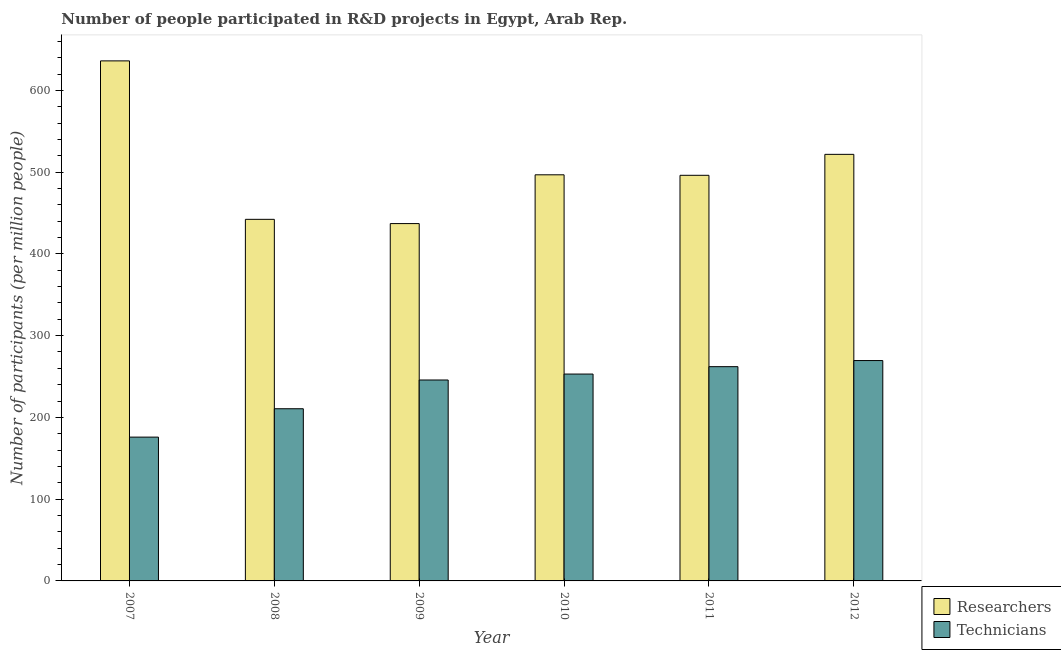How many groups of bars are there?
Offer a terse response. 6. How many bars are there on the 6th tick from the right?
Offer a terse response. 2. What is the label of the 6th group of bars from the left?
Offer a terse response. 2012. In how many cases, is the number of bars for a given year not equal to the number of legend labels?
Your answer should be compact. 0. What is the number of technicians in 2009?
Keep it short and to the point. 245.77. Across all years, what is the maximum number of researchers?
Give a very brief answer. 636.08. Across all years, what is the minimum number of researchers?
Your answer should be compact. 437.06. In which year was the number of researchers maximum?
Give a very brief answer. 2007. What is the total number of technicians in the graph?
Your response must be concise. 1416.87. What is the difference between the number of researchers in 2011 and that in 2012?
Offer a terse response. -25.62. What is the difference between the number of researchers in 2011 and the number of technicians in 2007?
Provide a short and direct response. -139.96. What is the average number of researchers per year?
Offer a very short reply. 505. What is the ratio of the number of researchers in 2008 to that in 2011?
Ensure brevity in your answer.  0.89. What is the difference between the highest and the second highest number of researchers?
Provide a short and direct response. 114.34. What is the difference between the highest and the lowest number of researchers?
Provide a succinct answer. 199.02. What does the 1st bar from the left in 2008 represents?
Your response must be concise. Researchers. What does the 1st bar from the right in 2008 represents?
Make the answer very short. Technicians. Are all the bars in the graph horizontal?
Your answer should be compact. No. What is the difference between two consecutive major ticks on the Y-axis?
Give a very brief answer. 100. Does the graph contain grids?
Offer a terse response. No. Where does the legend appear in the graph?
Your answer should be compact. Bottom right. How many legend labels are there?
Your response must be concise. 2. How are the legend labels stacked?
Keep it short and to the point. Vertical. What is the title of the graph?
Give a very brief answer. Number of people participated in R&D projects in Egypt, Arab Rep. What is the label or title of the Y-axis?
Keep it short and to the point. Number of participants (per million people). What is the Number of participants (per million people) in Researchers in 2007?
Your answer should be compact. 636.08. What is the Number of participants (per million people) in Technicians in 2007?
Offer a very short reply. 175.89. What is the Number of participants (per million people) of Researchers in 2008?
Ensure brevity in your answer.  442.27. What is the Number of participants (per million people) in Technicians in 2008?
Your answer should be compact. 210.6. What is the Number of participants (per million people) in Researchers in 2009?
Give a very brief answer. 437.06. What is the Number of participants (per million people) in Technicians in 2009?
Offer a very short reply. 245.77. What is the Number of participants (per million people) in Researchers in 2010?
Your answer should be very brief. 496.73. What is the Number of participants (per million people) in Technicians in 2010?
Make the answer very short. 253.02. What is the Number of participants (per million people) in Researchers in 2011?
Provide a succinct answer. 496.12. What is the Number of participants (per million people) in Technicians in 2011?
Offer a very short reply. 262.07. What is the Number of participants (per million people) in Researchers in 2012?
Provide a short and direct response. 521.74. What is the Number of participants (per million people) in Technicians in 2012?
Your answer should be compact. 269.53. Across all years, what is the maximum Number of participants (per million people) of Researchers?
Your answer should be compact. 636.08. Across all years, what is the maximum Number of participants (per million people) in Technicians?
Your answer should be compact. 269.53. Across all years, what is the minimum Number of participants (per million people) in Researchers?
Offer a terse response. 437.06. Across all years, what is the minimum Number of participants (per million people) in Technicians?
Offer a very short reply. 175.89. What is the total Number of participants (per million people) in Researchers in the graph?
Your answer should be compact. 3029.99. What is the total Number of participants (per million people) of Technicians in the graph?
Offer a very short reply. 1416.87. What is the difference between the Number of participants (per million people) in Researchers in 2007 and that in 2008?
Offer a very short reply. 193.81. What is the difference between the Number of participants (per million people) in Technicians in 2007 and that in 2008?
Your answer should be very brief. -34.71. What is the difference between the Number of participants (per million people) in Researchers in 2007 and that in 2009?
Make the answer very short. 199.02. What is the difference between the Number of participants (per million people) in Technicians in 2007 and that in 2009?
Ensure brevity in your answer.  -69.88. What is the difference between the Number of participants (per million people) in Researchers in 2007 and that in 2010?
Make the answer very short. 139.35. What is the difference between the Number of participants (per million people) in Technicians in 2007 and that in 2010?
Your answer should be very brief. -77.13. What is the difference between the Number of participants (per million people) in Researchers in 2007 and that in 2011?
Ensure brevity in your answer.  139.96. What is the difference between the Number of participants (per million people) in Technicians in 2007 and that in 2011?
Make the answer very short. -86.18. What is the difference between the Number of participants (per million people) in Researchers in 2007 and that in 2012?
Give a very brief answer. 114.34. What is the difference between the Number of participants (per million people) of Technicians in 2007 and that in 2012?
Provide a short and direct response. -93.64. What is the difference between the Number of participants (per million people) of Researchers in 2008 and that in 2009?
Keep it short and to the point. 5.21. What is the difference between the Number of participants (per million people) in Technicians in 2008 and that in 2009?
Provide a short and direct response. -35.17. What is the difference between the Number of participants (per million people) in Researchers in 2008 and that in 2010?
Provide a succinct answer. -54.46. What is the difference between the Number of participants (per million people) in Technicians in 2008 and that in 2010?
Keep it short and to the point. -42.42. What is the difference between the Number of participants (per million people) of Researchers in 2008 and that in 2011?
Your answer should be very brief. -53.85. What is the difference between the Number of participants (per million people) of Technicians in 2008 and that in 2011?
Your answer should be very brief. -51.47. What is the difference between the Number of participants (per million people) of Researchers in 2008 and that in 2012?
Keep it short and to the point. -79.47. What is the difference between the Number of participants (per million people) in Technicians in 2008 and that in 2012?
Ensure brevity in your answer.  -58.93. What is the difference between the Number of participants (per million people) in Researchers in 2009 and that in 2010?
Give a very brief answer. -59.67. What is the difference between the Number of participants (per million people) of Technicians in 2009 and that in 2010?
Offer a very short reply. -7.25. What is the difference between the Number of participants (per million people) in Researchers in 2009 and that in 2011?
Offer a very short reply. -59.06. What is the difference between the Number of participants (per million people) in Technicians in 2009 and that in 2011?
Make the answer very short. -16.3. What is the difference between the Number of participants (per million people) in Researchers in 2009 and that in 2012?
Provide a succinct answer. -84.68. What is the difference between the Number of participants (per million people) in Technicians in 2009 and that in 2012?
Keep it short and to the point. -23.76. What is the difference between the Number of participants (per million people) of Researchers in 2010 and that in 2011?
Provide a short and direct response. 0.61. What is the difference between the Number of participants (per million people) of Technicians in 2010 and that in 2011?
Your response must be concise. -9.05. What is the difference between the Number of participants (per million people) in Researchers in 2010 and that in 2012?
Offer a very short reply. -25.01. What is the difference between the Number of participants (per million people) of Technicians in 2010 and that in 2012?
Provide a short and direct response. -16.51. What is the difference between the Number of participants (per million people) in Researchers in 2011 and that in 2012?
Provide a short and direct response. -25.62. What is the difference between the Number of participants (per million people) in Technicians in 2011 and that in 2012?
Provide a short and direct response. -7.46. What is the difference between the Number of participants (per million people) in Researchers in 2007 and the Number of participants (per million people) in Technicians in 2008?
Ensure brevity in your answer.  425.48. What is the difference between the Number of participants (per million people) of Researchers in 2007 and the Number of participants (per million people) of Technicians in 2009?
Offer a terse response. 390.31. What is the difference between the Number of participants (per million people) in Researchers in 2007 and the Number of participants (per million people) in Technicians in 2010?
Offer a very short reply. 383.06. What is the difference between the Number of participants (per million people) in Researchers in 2007 and the Number of participants (per million people) in Technicians in 2011?
Keep it short and to the point. 374.01. What is the difference between the Number of participants (per million people) of Researchers in 2007 and the Number of participants (per million people) of Technicians in 2012?
Your answer should be compact. 366.55. What is the difference between the Number of participants (per million people) in Researchers in 2008 and the Number of participants (per million people) in Technicians in 2009?
Make the answer very short. 196.5. What is the difference between the Number of participants (per million people) of Researchers in 2008 and the Number of participants (per million people) of Technicians in 2010?
Keep it short and to the point. 189.25. What is the difference between the Number of participants (per million people) of Researchers in 2008 and the Number of participants (per million people) of Technicians in 2011?
Make the answer very short. 180.2. What is the difference between the Number of participants (per million people) in Researchers in 2008 and the Number of participants (per million people) in Technicians in 2012?
Ensure brevity in your answer.  172.74. What is the difference between the Number of participants (per million people) in Researchers in 2009 and the Number of participants (per million people) in Technicians in 2010?
Offer a terse response. 184.04. What is the difference between the Number of participants (per million people) of Researchers in 2009 and the Number of participants (per million people) of Technicians in 2011?
Your answer should be compact. 174.99. What is the difference between the Number of participants (per million people) of Researchers in 2009 and the Number of participants (per million people) of Technicians in 2012?
Give a very brief answer. 167.53. What is the difference between the Number of participants (per million people) of Researchers in 2010 and the Number of participants (per million people) of Technicians in 2011?
Ensure brevity in your answer.  234.66. What is the difference between the Number of participants (per million people) of Researchers in 2010 and the Number of participants (per million people) of Technicians in 2012?
Your answer should be compact. 227.2. What is the difference between the Number of participants (per million people) of Researchers in 2011 and the Number of participants (per million people) of Technicians in 2012?
Offer a very short reply. 226.59. What is the average Number of participants (per million people) in Researchers per year?
Offer a very short reply. 505. What is the average Number of participants (per million people) of Technicians per year?
Your answer should be very brief. 236.14. In the year 2007, what is the difference between the Number of participants (per million people) in Researchers and Number of participants (per million people) in Technicians?
Offer a very short reply. 460.19. In the year 2008, what is the difference between the Number of participants (per million people) of Researchers and Number of participants (per million people) of Technicians?
Your answer should be very brief. 231.67. In the year 2009, what is the difference between the Number of participants (per million people) of Researchers and Number of participants (per million people) of Technicians?
Your response must be concise. 191.29. In the year 2010, what is the difference between the Number of participants (per million people) of Researchers and Number of participants (per million people) of Technicians?
Your response must be concise. 243.71. In the year 2011, what is the difference between the Number of participants (per million people) of Researchers and Number of participants (per million people) of Technicians?
Give a very brief answer. 234.05. In the year 2012, what is the difference between the Number of participants (per million people) of Researchers and Number of participants (per million people) of Technicians?
Your answer should be very brief. 252.21. What is the ratio of the Number of participants (per million people) in Researchers in 2007 to that in 2008?
Ensure brevity in your answer.  1.44. What is the ratio of the Number of participants (per million people) of Technicians in 2007 to that in 2008?
Provide a short and direct response. 0.84. What is the ratio of the Number of participants (per million people) of Researchers in 2007 to that in 2009?
Make the answer very short. 1.46. What is the ratio of the Number of participants (per million people) of Technicians in 2007 to that in 2009?
Provide a succinct answer. 0.72. What is the ratio of the Number of participants (per million people) in Researchers in 2007 to that in 2010?
Provide a succinct answer. 1.28. What is the ratio of the Number of participants (per million people) in Technicians in 2007 to that in 2010?
Offer a very short reply. 0.7. What is the ratio of the Number of participants (per million people) in Researchers in 2007 to that in 2011?
Provide a succinct answer. 1.28. What is the ratio of the Number of participants (per million people) in Technicians in 2007 to that in 2011?
Provide a succinct answer. 0.67. What is the ratio of the Number of participants (per million people) of Researchers in 2007 to that in 2012?
Offer a very short reply. 1.22. What is the ratio of the Number of participants (per million people) in Technicians in 2007 to that in 2012?
Your response must be concise. 0.65. What is the ratio of the Number of participants (per million people) in Researchers in 2008 to that in 2009?
Provide a short and direct response. 1.01. What is the ratio of the Number of participants (per million people) of Technicians in 2008 to that in 2009?
Offer a terse response. 0.86. What is the ratio of the Number of participants (per million people) in Researchers in 2008 to that in 2010?
Offer a terse response. 0.89. What is the ratio of the Number of participants (per million people) in Technicians in 2008 to that in 2010?
Your response must be concise. 0.83. What is the ratio of the Number of participants (per million people) of Researchers in 2008 to that in 2011?
Offer a terse response. 0.89. What is the ratio of the Number of participants (per million people) in Technicians in 2008 to that in 2011?
Offer a terse response. 0.8. What is the ratio of the Number of participants (per million people) of Researchers in 2008 to that in 2012?
Offer a very short reply. 0.85. What is the ratio of the Number of participants (per million people) in Technicians in 2008 to that in 2012?
Offer a very short reply. 0.78. What is the ratio of the Number of participants (per million people) in Researchers in 2009 to that in 2010?
Your response must be concise. 0.88. What is the ratio of the Number of participants (per million people) in Technicians in 2009 to that in 2010?
Ensure brevity in your answer.  0.97. What is the ratio of the Number of participants (per million people) in Researchers in 2009 to that in 2011?
Make the answer very short. 0.88. What is the ratio of the Number of participants (per million people) in Technicians in 2009 to that in 2011?
Make the answer very short. 0.94. What is the ratio of the Number of participants (per million people) in Researchers in 2009 to that in 2012?
Your response must be concise. 0.84. What is the ratio of the Number of participants (per million people) of Technicians in 2009 to that in 2012?
Provide a short and direct response. 0.91. What is the ratio of the Number of participants (per million people) of Technicians in 2010 to that in 2011?
Provide a succinct answer. 0.97. What is the ratio of the Number of participants (per million people) in Researchers in 2010 to that in 2012?
Your answer should be very brief. 0.95. What is the ratio of the Number of participants (per million people) of Technicians in 2010 to that in 2012?
Provide a succinct answer. 0.94. What is the ratio of the Number of participants (per million people) in Researchers in 2011 to that in 2012?
Your answer should be very brief. 0.95. What is the ratio of the Number of participants (per million people) of Technicians in 2011 to that in 2012?
Your response must be concise. 0.97. What is the difference between the highest and the second highest Number of participants (per million people) in Researchers?
Offer a terse response. 114.34. What is the difference between the highest and the second highest Number of participants (per million people) of Technicians?
Ensure brevity in your answer.  7.46. What is the difference between the highest and the lowest Number of participants (per million people) of Researchers?
Give a very brief answer. 199.02. What is the difference between the highest and the lowest Number of participants (per million people) of Technicians?
Keep it short and to the point. 93.64. 